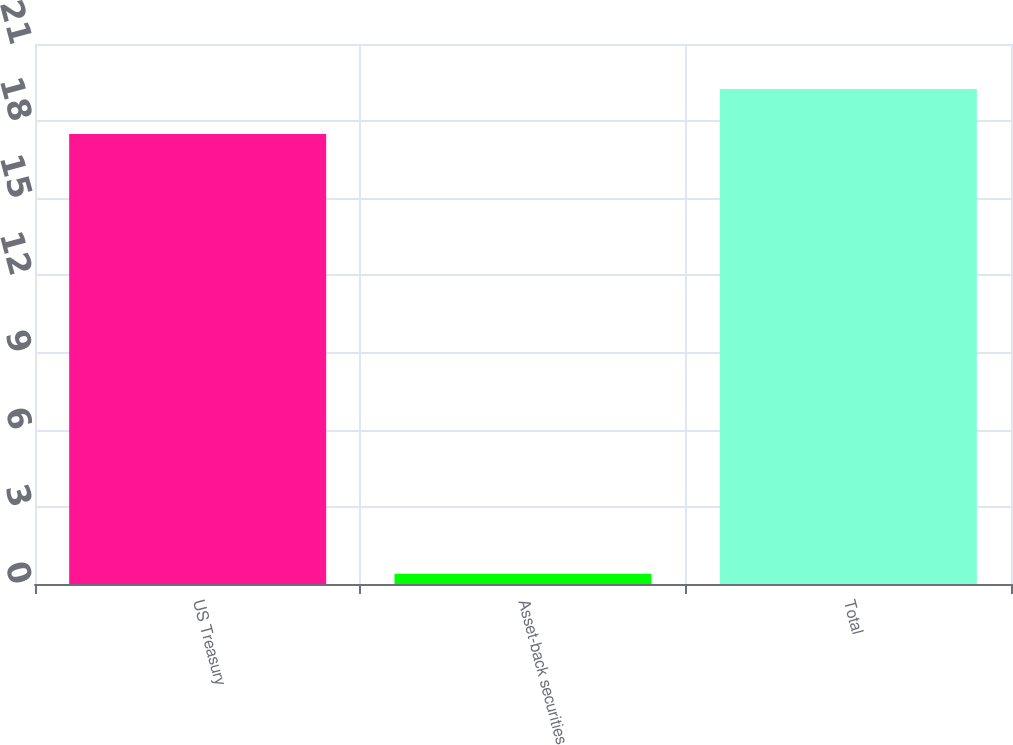<chart> <loc_0><loc_0><loc_500><loc_500><bar_chart><fcel>US Treasury<fcel>Asset-back securities<fcel>Total<nl><fcel>17.5<fcel>0.4<fcel>19.25<nl></chart> 